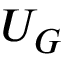Convert formula to latex. <formula><loc_0><loc_0><loc_500><loc_500>U _ { G }</formula> 